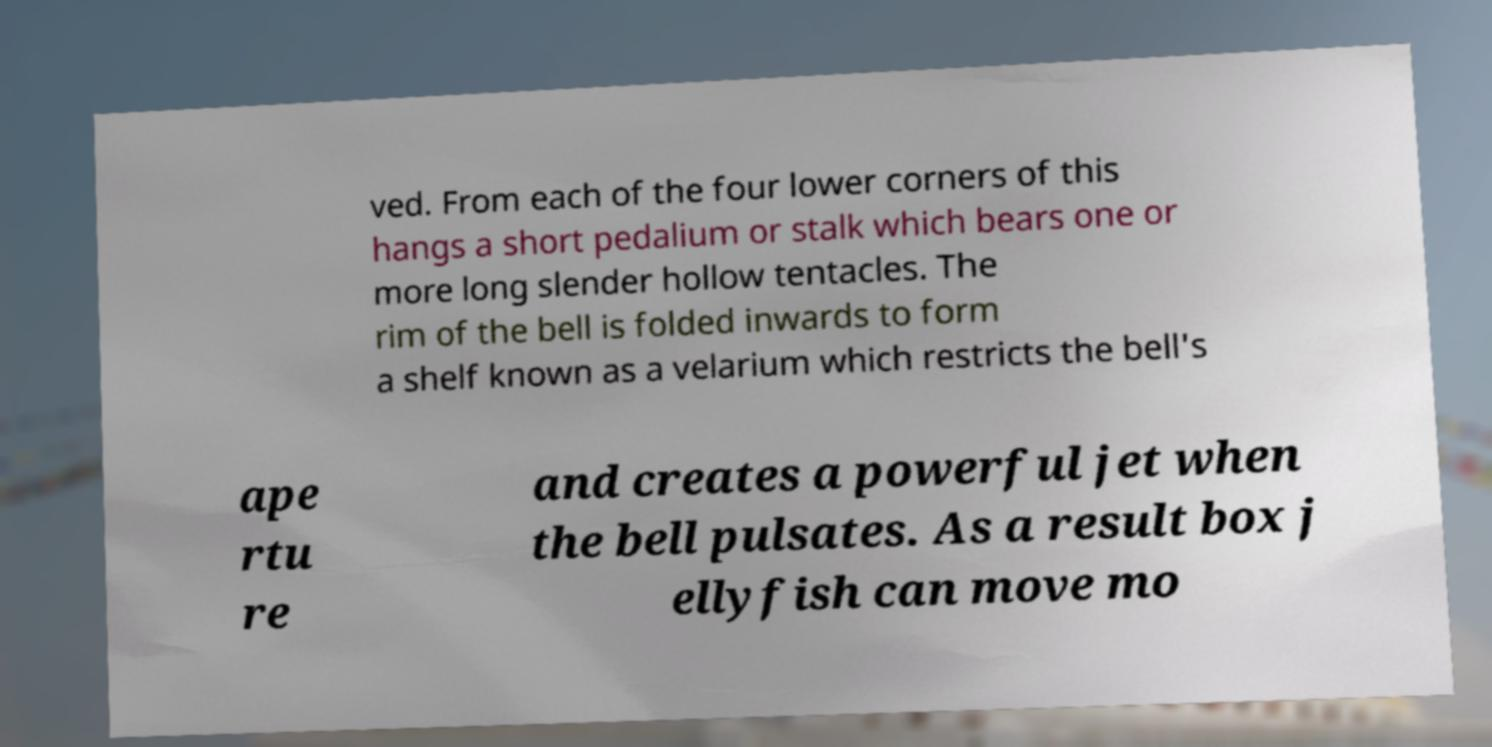Can you read and provide the text displayed in the image?This photo seems to have some interesting text. Can you extract and type it out for me? ved. From each of the four lower corners of this hangs a short pedalium or stalk which bears one or more long slender hollow tentacles. The rim of the bell is folded inwards to form a shelf known as a velarium which restricts the bell's ape rtu re and creates a powerful jet when the bell pulsates. As a result box j ellyfish can move mo 